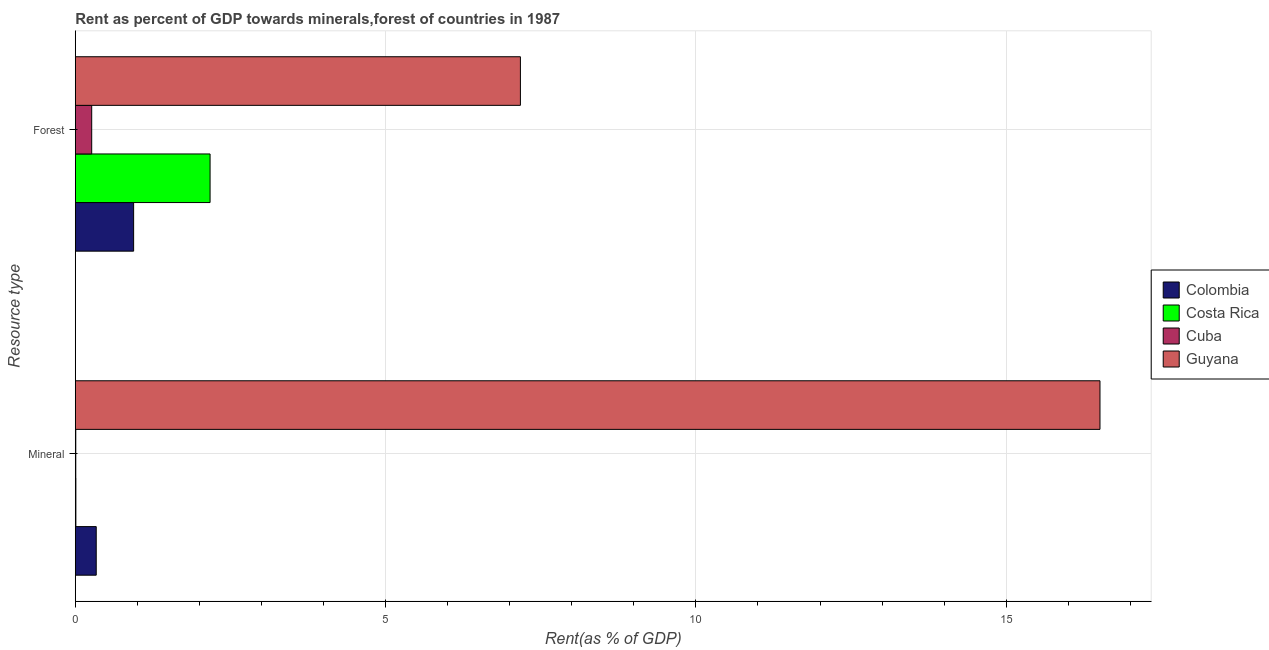How many bars are there on the 2nd tick from the top?
Give a very brief answer. 4. What is the label of the 1st group of bars from the top?
Give a very brief answer. Forest. What is the mineral rent in Costa Rica?
Your response must be concise. 0.01. Across all countries, what is the maximum mineral rent?
Give a very brief answer. 16.51. Across all countries, what is the minimum forest rent?
Offer a terse response. 0.26. In which country was the mineral rent maximum?
Keep it short and to the point. Guyana. In which country was the forest rent minimum?
Offer a very short reply. Cuba. What is the total forest rent in the graph?
Provide a short and direct response. 10.55. What is the difference between the mineral rent in Costa Rica and that in Colombia?
Offer a very short reply. -0.33. What is the difference between the forest rent in Costa Rica and the mineral rent in Colombia?
Make the answer very short. 1.83. What is the average forest rent per country?
Provide a short and direct response. 2.64. What is the difference between the mineral rent and forest rent in Colombia?
Give a very brief answer. -0.6. In how many countries, is the mineral rent greater than 6 %?
Ensure brevity in your answer.  1. What is the ratio of the mineral rent in Costa Rica to that in Colombia?
Keep it short and to the point. 0.03. Is the mineral rent in Costa Rica less than that in Colombia?
Keep it short and to the point. Yes. In how many countries, is the forest rent greater than the average forest rent taken over all countries?
Your answer should be compact. 1. What does the 3rd bar from the top in Mineral represents?
Offer a very short reply. Costa Rica. What does the 4th bar from the bottom in Forest represents?
Provide a succinct answer. Guyana. How many bars are there?
Offer a very short reply. 8. How many countries are there in the graph?
Offer a terse response. 4. Are the values on the major ticks of X-axis written in scientific E-notation?
Ensure brevity in your answer.  No. Does the graph contain any zero values?
Your response must be concise. No. How are the legend labels stacked?
Provide a short and direct response. Vertical. What is the title of the graph?
Give a very brief answer. Rent as percent of GDP towards minerals,forest of countries in 1987. Does "Dominica" appear as one of the legend labels in the graph?
Ensure brevity in your answer.  No. What is the label or title of the X-axis?
Make the answer very short. Rent(as % of GDP). What is the label or title of the Y-axis?
Make the answer very short. Resource type. What is the Rent(as % of GDP) in Colombia in Mineral?
Keep it short and to the point. 0.34. What is the Rent(as % of GDP) in Costa Rica in Mineral?
Ensure brevity in your answer.  0.01. What is the Rent(as % of GDP) in Cuba in Mineral?
Make the answer very short. 0.01. What is the Rent(as % of GDP) in Guyana in Mineral?
Give a very brief answer. 16.51. What is the Rent(as % of GDP) in Colombia in Forest?
Give a very brief answer. 0.94. What is the Rent(as % of GDP) in Costa Rica in Forest?
Provide a short and direct response. 2.17. What is the Rent(as % of GDP) of Cuba in Forest?
Keep it short and to the point. 0.26. What is the Rent(as % of GDP) in Guyana in Forest?
Offer a terse response. 7.17. Across all Resource type, what is the maximum Rent(as % of GDP) in Colombia?
Provide a succinct answer. 0.94. Across all Resource type, what is the maximum Rent(as % of GDP) in Costa Rica?
Ensure brevity in your answer.  2.17. Across all Resource type, what is the maximum Rent(as % of GDP) of Cuba?
Provide a short and direct response. 0.26. Across all Resource type, what is the maximum Rent(as % of GDP) of Guyana?
Give a very brief answer. 16.51. Across all Resource type, what is the minimum Rent(as % of GDP) in Colombia?
Provide a succinct answer. 0.34. Across all Resource type, what is the minimum Rent(as % of GDP) of Costa Rica?
Keep it short and to the point. 0.01. Across all Resource type, what is the minimum Rent(as % of GDP) of Cuba?
Your answer should be very brief. 0.01. Across all Resource type, what is the minimum Rent(as % of GDP) of Guyana?
Your response must be concise. 7.17. What is the total Rent(as % of GDP) of Colombia in the graph?
Ensure brevity in your answer.  1.28. What is the total Rent(as % of GDP) in Costa Rica in the graph?
Ensure brevity in your answer.  2.18. What is the total Rent(as % of GDP) in Cuba in the graph?
Provide a short and direct response. 0.27. What is the total Rent(as % of GDP) of Guyana in the graph?
Your response must be concise. 23.68. What is the difference between the Rent(as % of GDP) in Colombia in Mineral and that in Forest?
Your answer should be compact. -0.6. What is the difference between the Rent(as % of GDP) of Costa Rica in Mineral and that in Forest?
Your answer should be very brief. -2.16. What is the difference between the Rent(as % of GDP) of Cuba in Mineral and that in Forest?
Offer a very short reply. -0.26. What is the difference between the Rent(as % of GDP) in Guyana in Mineral and that in Forest?
Offer a very short reply. 9.34. What is the difference between the Rent(as % of GDP) in Colombia in Mineral and the Rent(as % of GDP) in Costa Rica in Forest?
Your answer should be compact. -1.83. What is the difference between the Rent(as % of GDP) in Colombia in Mineral and the Rent(as % of GDP) in Cuba in Forest?
Offer a very short reply. 0.07. What is the difference between the Rent(as % of GDP) in Colombia in Mineral and the Rent(as % of GDP) in Guyana in Forest?
Ensure brevity in your answer.  -6.84. What is the difference between the Rent(as % of GDP) in Costa Rica in Mineral and the Rent(as % of GDP) in Cuba in Forest?
Make the answer very short. -0.26. What is the difference between the Rent(as % of GDP) of Costa Rica in Mineral and the Rent(as % of GDP) of Guyana in Forest?
Offer a terse response. -7.16. What is the difference between the Rent(as % of GDP) in Cuba in Mineral and the Rent(as % of GDP) in Guyana in Forest?
Offer a terse response. -7.16. What is the average Rent(as % of GDP) in Colombia per Resource type?
Offer a very short reply. 0.64. What is the average Rent(as % of GDP) in Costa Rica per Resource type?
Provide a short and direct response. 1.09. What is the average Rent(as % of GDP) of Cuba per Resource type?
Your answer should be compact. 0.14. What is the average Rent(as % of GDP) in Guyana per Resource type?
Your answer should be compact. 11.84. What is the difference between the Rent(as % of GDP) of Colombia and Rent(as % of GDP) of Costa Rica in Mineral?
Your response must be concise. 0.33. What is the difference between the Rent(as % of GDP) of Colombia and Rent(as % of GDP) of Cuba in Mineral?
Offer a very short reply. 0.33. What is the difference between the Rent(as % of GDP) of Colombia and Rent(as % of GDP) of Guyana in Mineral?
Provide a succinct answer. -16.17. What is the difference between the Rent(as % of GDP) of Costa Rica and Rent(as % of GDP) of Cuba in Mineral?
Your answer should be compact. 0. What is the difference between the Rent(as % of GDP) of Costa Rica and Rent(as % of GDP) of Guyana in Mineral?
Your answer should be very brief. -16.5. What is the difference between the Rent(as % of GDP) in Cuba and Rent(as % of GDP) in Guyana in Mineral?
Your answer should be compact. -16.5. What is the difference between the Rent(as % of GDP) in Colombia and Rent(as % of GDP) in Costa Rica in Forest?
Your response must be concise. -1.23. What is the difference between the Rent(as % of GDP) in Colombia and Rent(as % of GDP) in Cuba in Forest?
Offer a terse response. 0.68. What is the difference between the Rent(as % of GDP) of Colombia and Rent(as % of GDP) of Guyana in Forest?
Your response must be concise. -6.23. What is the difference between the Rent(as % of GDP) of Costa Rica and Rent(as % of GDP) of Cuba in Forest?
Offer a very short reply. 1.91. What is the difference between the Rent(as % of GDP) of Costa Rica and Rent(as % of GDP) of Guyana in Forest?
Provide a succinct answer. -5. What is the difference between the Rent(as % of GDP) of Cuba and Rent(as % of GDP) of Guyana in Forest?
Keep it short and to the point. -6.91. What is the ratio of the Rent(as % of GDP) in Colombia in Mineral to that in Forest?
Give a very brief answer. 0.36. What is the ratio of the Rent(as % of GDP) in Costa Rica in Mineral to that in Forest?
Provide a short and direct response. 0. What is the ratio of the Rent(as % of GDP) of Cuba in Mineral to that in Forest?
Make the answer very short. 0.03. What is the ratio of the Rent(as % of GDP) of Guyana in Mineral to that in Forest?
Your response must be concise. 2.3. What is the difference between the highest and the second highest Rent(as % of GDP) of Colombia?
Your answer should be very brief. 0.6. What is the difference between the highest and the second highest Rent(as % of GDP) in Costa Rica?
Provide a succinct answer. 2.16. What is the difference between the highest and the second highest Rent(as % of GDP) in Cuba?
Your answer should be very brief. 0.26. What is the difference between the highest and the second highest Rent(as % of GDP) in Guyana?
Give a very brief answer. 9.34. What is the difference between the highest and the lowest Rent(as % of GDP) of Colombia?
Offer a very short reply. 0.6. What is the difference between the highest and the lowest Rent(as % of GDP) in Costa Rica?
Offer a very short reply. 2.16. What is the difference between the highest and the lowest Rent(as % of GDP) in Cuba?
Give a very brief answer. 0.26. What is the difference between the highest and the lowest Rent(as % of GDP) in Guyana?
Your response must be concise. 9.34. 